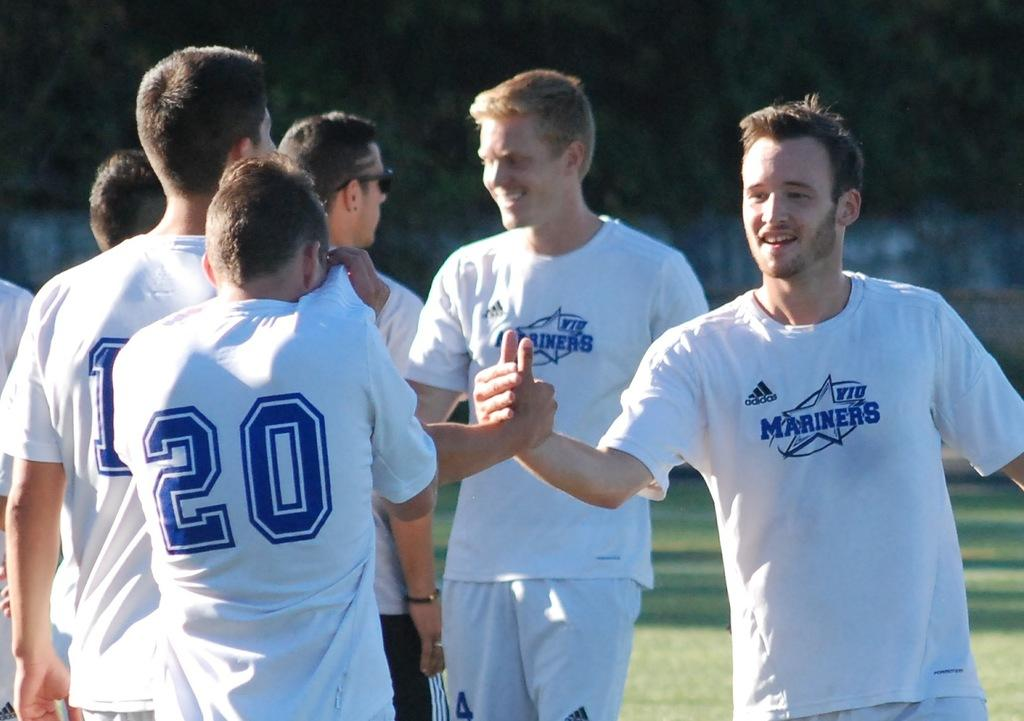<image>
Provide a brief description of the given image. Men wearing WIU Mariners uniforms are shaking hands on the field. 